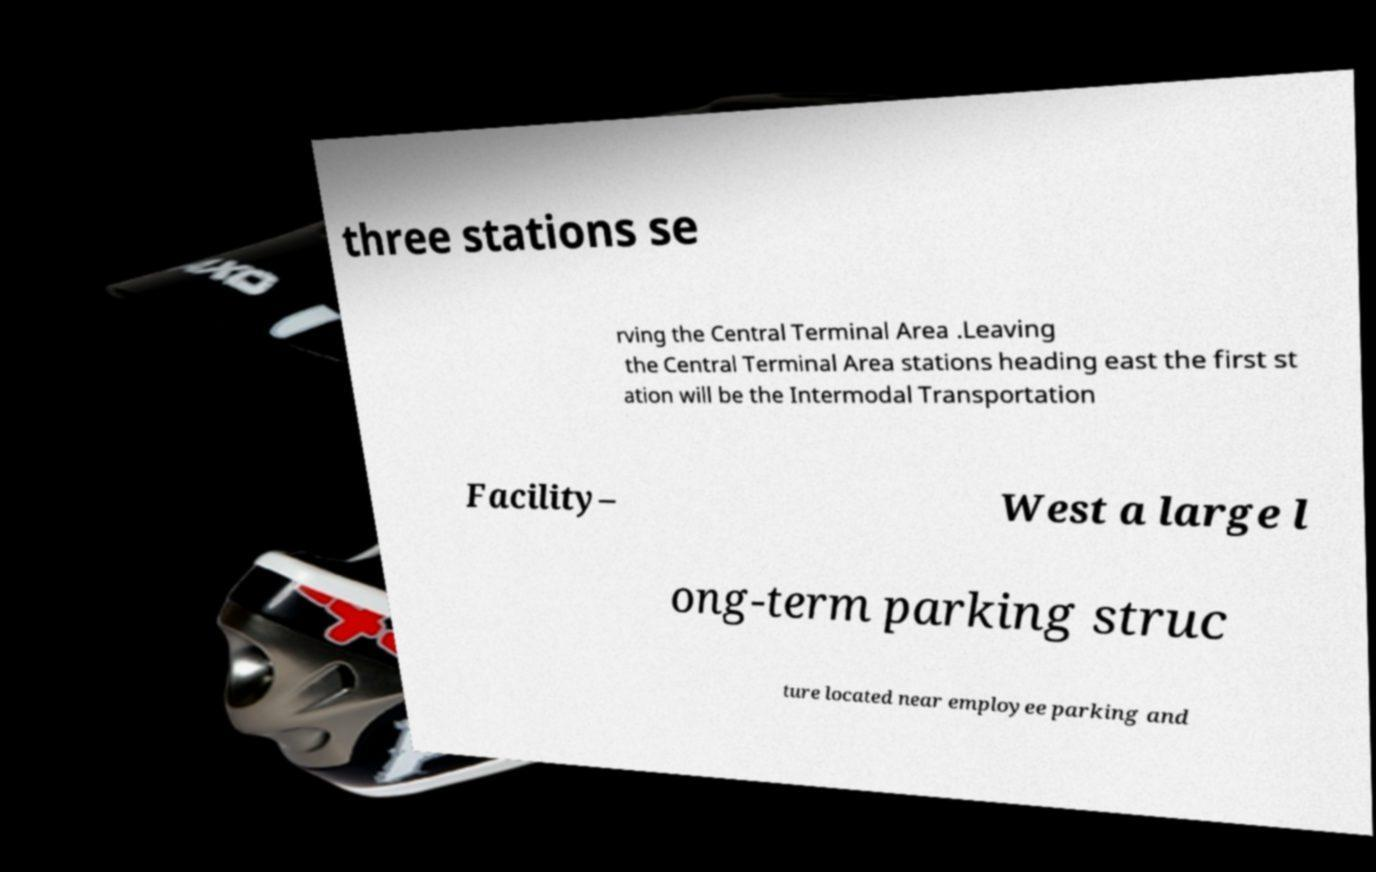There's text embedded in this image that I need extracted. Can you transcribe it verbatim? three stations se rving the Central Terminal Area .Leaving the Central Terminal Area stations heading east the first st ation will be the Intermodal Transportation Facility– West a large l ong-term parking struc ture located near employee parking and 